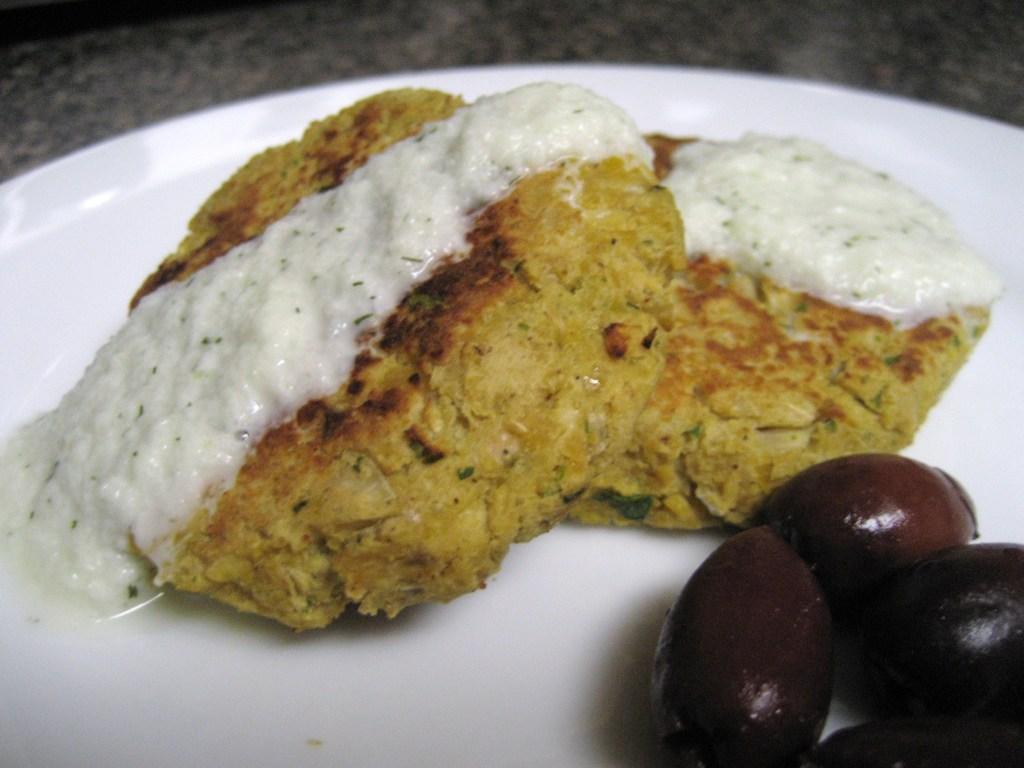Describe this image in one or two sentences. In this there is a plate, in that plate there is a food item, in the background it is blurred. 